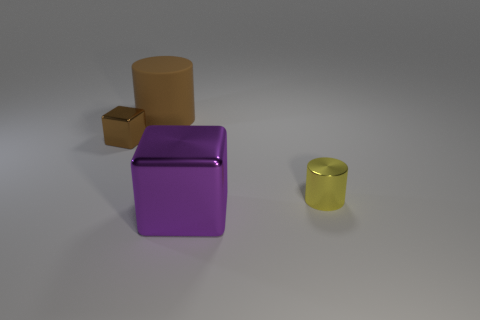There is a brown object in front of the brown rubber object; is it the same size as the yellow thing?
Make the answer very short. Yes. What material is the cylinder that is on the right side of the matte cylinder?
Your answer should be compact. Metal. Is the number of objects greater than the number of brown matte cylinders?
Offer a very short reply. Yes. What number of objects are either things on the left side of the brown matte thing or small yellow things?
Offer a terse response. 2. What number of yellow things are to the right of the small shiny thing that is on the right side of the big rubber object?
Make the answer very short. 0. What is the size of the metallic block right of the brown object that is behind the small object on the left side of the yellow cylinder?
Your answer should be compact. Large. Is the color of the cylinder that is on the left side of the tiny cylinder the same as the small cube?
Make the answer very short. Yes. There is a yellow thing that is the same shape as the large brown object; what is its size?
Your answer should be compact. Small. How many objects are cylinders in front of the big cylinder or things that are to the right of the tiny brown shiny block?
Give a very brief answer. 3. There is a thing right of the big thing in front of the small brown object; what is its shape?
Your answer should be compact. Cylinder. 